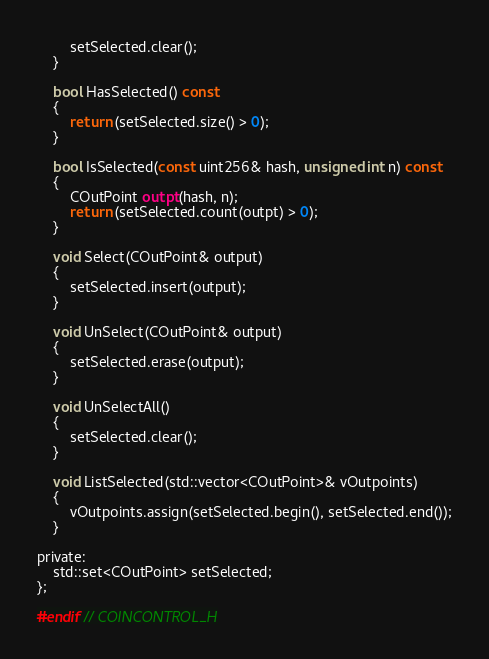<code> <loc_0><loc_0><loc_500><loc_500><_C_>        setSelected.clear();
    }

    bool HasSelected() const
    {
        return (setSelected.size() > 0);
    }

    bool IsSelected(const uint256& hash, unsigned int n) const
    {
        COutPoint outpt(hash, n);
        return (setSelected.count(outpt) > 0);
    }

    void Select(COutPoint& output)
    {
        setSelected.insert(output);
    }

    void UnSelect(COutPoint& output)
    {
        setSelected.erase(output);
    }

    void UnSelectAll()
    {
        setSelected.clear();
    }

    void ListSelected(std::vector<COutPoint>& vOutpoints)
    {
        vOutpoints.assign(setSelected.begin(), setSelected.end());
    }

private:
    std::set<COutPoint> setSelected;
};

#endif // COINCONTROL_H
</code> 